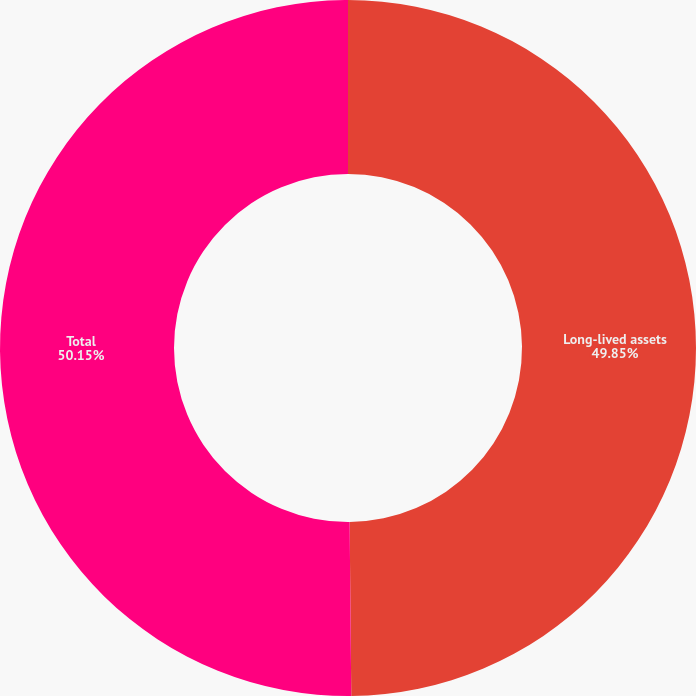Convert chart to OTSL. <chart><loc_0><loc_0><loc_500><loc_500><pie_chart><fcel>Long-lived assets<fcel>Total<nl><fcel>49.85%<fcel>50.15%<nl></chart> 